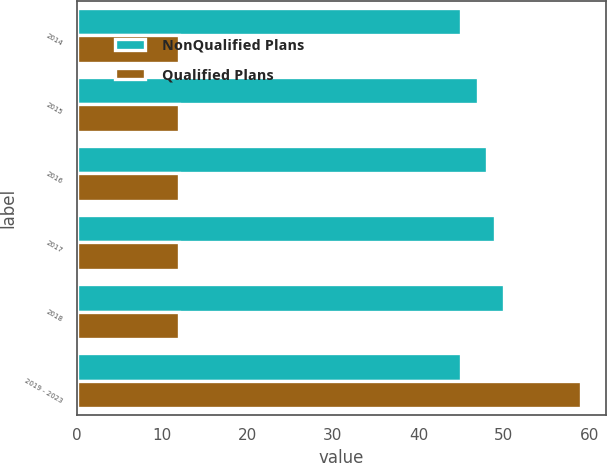<chart> <loc_0><loc_0><loc_500><loc_500><stacked_bar_chart><ecel><fcel>2014<fcel>2015<fcel>2016<fcel>2017<fcel>2018<fcel>2019 - 2023<nl><fcel>NonQualified Plans<fcel>45<fcel>47<fcel>48<fcel>49<fcel>50<fcel>45<nl><fcel>Qualified Plans<fcel>12<fcel>12<fcel>12<fcel>12<fcel>12<fcel>59<nl></chart> 